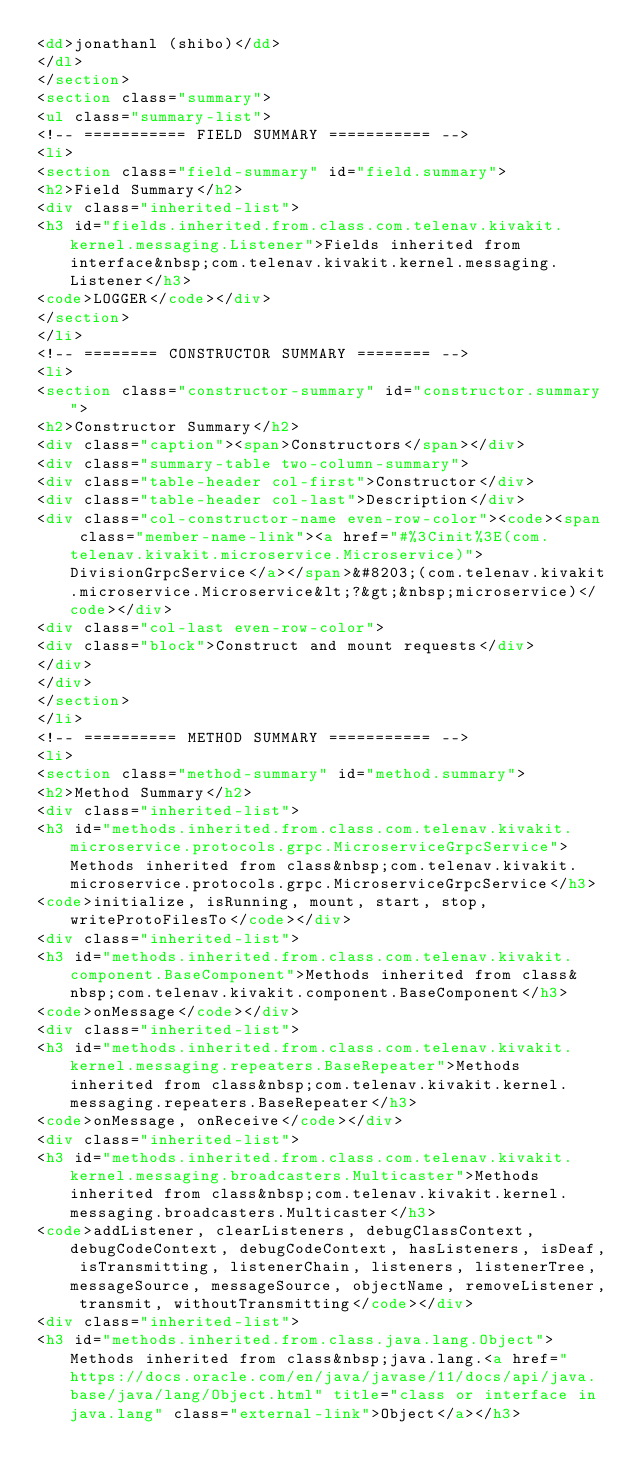Convert code to text. <code><loc_0><loc_0><loc_500><loc_500><_HTML_><dd>jonathanl (shibo)</dd>
</dl>
</section>
<section class="summary">
<ul class="summary-list">
<!-- =========== FIELD SUMMARY =========== -->
<li>
<section class="field-summary" id="field.summary">
<h2>Field Summary</h2>
<div class="inherited-list">
<h3 id="fields.inherited.from.class.com.telenav.kivakit.kernel.messaging.Listener">Fields inherited from interface&nbsp;com.telenav.kivakit.kernel.messaging.Listener</h3>
<code>LOGGER</code></div>
</section>
</li>
<!-- ======== CONSTRUCTOR SUMMARY ======== -->
<li>
<section class="constructor-summary" id="constructor.summary">
<h2>Constructor Summary</h2>
<div class="caption"><span>Constructors</span></div>
<div class="summary-table two-column-summary">
<div class="table-header col-first">Constructor</div>
<div class="table-header col-last">Description</div>
<div class="col-constructor-name even-row-color"><code><span class="member-name-link"><a href="#%3Cinit%3E(com.telenav.kivakit.microservice.Microservice)">DivisionGrpcService</a></span>&#8203;(com.telenav.kivakit.microservice.Microservice&lt;?&gt;&nbsp;microservice)</code></div>
<div class="col-last even-row-color">
<div class="block">Construct and mount requests</div>
</div>
</div>
</section>
</li>
<!-- ========== METHOD SUMMARY =========== -->
<li>
<section class="method-summary" id="method.summary">
<h2>Method Summary</h2>
<div class="inherited-list">
<h3 id="methods.inherited.from.class.com.telenav.kivakit.microservice.protocols.grpc.MicroserviceGrpcService">Methods inherited from class&nbsp;com.telenav.kivakit.microservice.protocols.grpc.MicroserviceGrpcService</h3>
<code>initialize, isRunning, mount, start, stop, writeProtoFilesTo</code></div>
<div class="inherited-list">
<h3 id="methods.inherited.from.class.com.telenav.kivakit.component.BaseComponent">Methods inherited from class&nbsp;com.telenav.kivakit.component.BaseComponent</h3>
<code>onMessage</code></div>
<div class="inherited-list">
<h3 id="methods.inherited.from.class.com.telenav.kivakit.kernel.messaging.repeaters.BaseRepeater">Methods inherited from class&nbsp;com.telenav.kivakit.kernel.messaging.repeaters.BaseRepeater</h3>
<code>onMessage, onReceive</code></div>
<div class="inherited-list">
<h3 id="methods.inherited.from.class.com.telenav.kivakit.kernel.messaging.broadcasters.Multicaster">Methods inherited from class&nbsp;com.telenav.kivakit.kernel.messaging.broadcasters.Multicaster</h3>
<code>addListener, clearListeners, debugClassContext, debugCodeContext, debugCodeContext, hasListeners, isDeaf, isTransmitting, listenerChain, listeners, listenerTree, messageSource, messageSource, objectName, removeListener, transmit, withoutTransmitting</code></div>
<div class="inherited-list">
<h3 id="methods.inherited.from.class.java.lang.Object">Methods inherited from class&nbsp;java.lang.<a href="https://docs.oracle.com/en/java/javase/11/docs/api/java.base/java/lang/Object.html" title="class or interface in java.lang" class="external-link">Object</a></h3></code> 